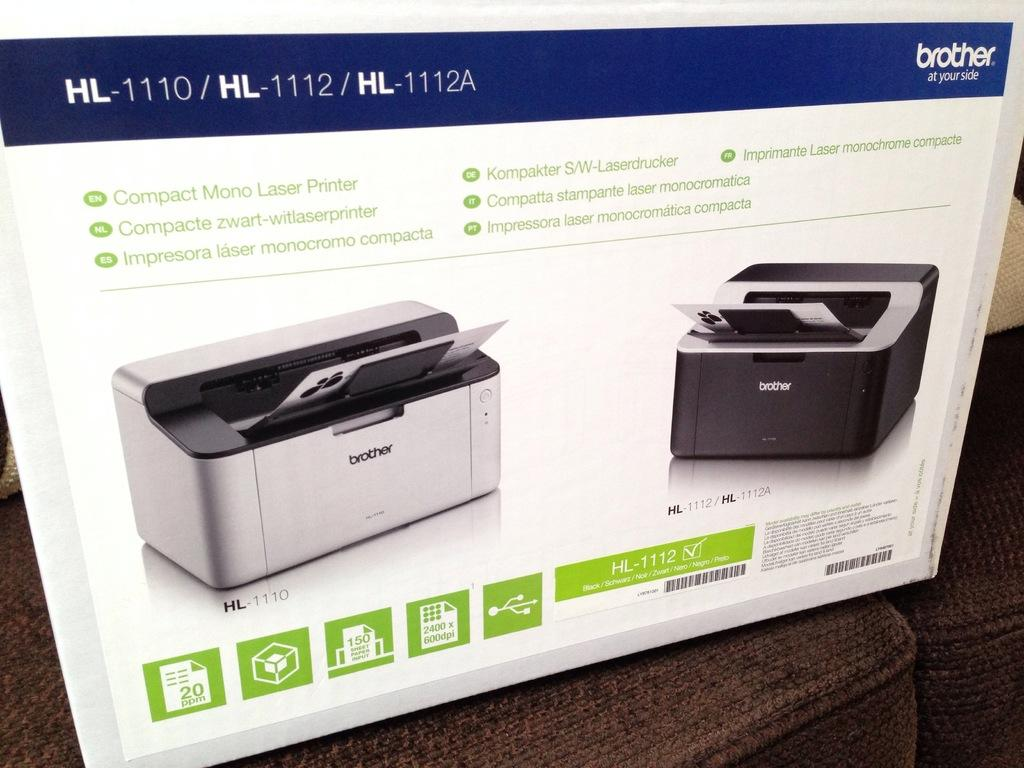<image>
Describe the image concisely. A box containing a Brother compact laser printer. 